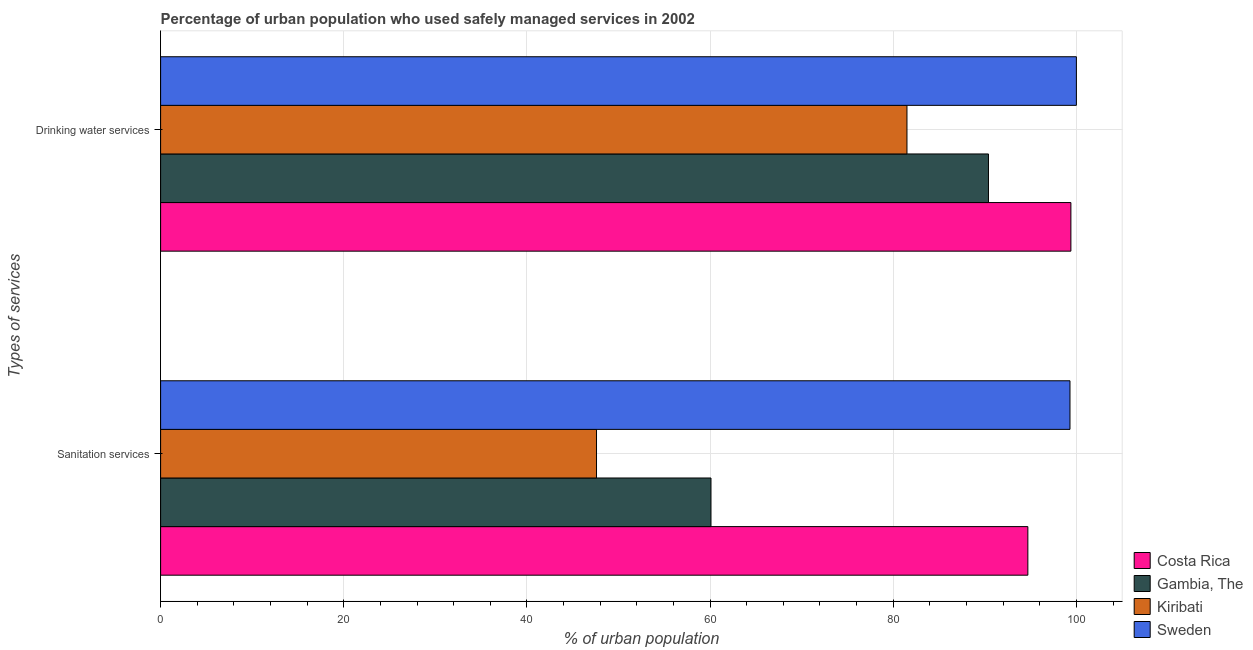How many groups of bars are there?
Offer a very short reply. 2. Are the number of bars per tick equal to the number of legend labels?
Give a very brief answer. Yes. How many bars are there on the 1st tick from the top?
Your response must be concise. 4. How many bars are there on the 1st tick from the bottom?
Make the answer very short. 4. What is the label of the 2nd group of bars from the top?
Give a very brief answer. Sanitation services. What is the percentage of urban population who used drinking water services in Costa Rica?
Keep it short and to the point. 99.4. Across all countries, what is the maximum percentage of urban population who used drinking water services?
Provide a short and direct response. 100. Across all countries, what is the minimum percentage of urban population who used sanitation services?
Your answer should be very brief. 47.6. In which country was the percentage of urban population who used drinking water services minimum?
Offer a terse response. Kiribati. What is the total percentage of urban population who used sanitation services in the graph?
Offer a very short reply. 301.7. What is the difference between the percentage of urban population who used drinking water services in Costa Rica and that in Sweden?
Your answer should be compact. -0.6. What is the difference between the percentage of urban population who used sanitation services in Costa Rica and the percentage of urban population who used drinking water services in Sweden?
Give a very brief answer. -5.3. What is the average percentage of urban population who used sanitation services per country?
Your answer should be very brief. 75.42. What is the difference between the percentage of urban population who used drinking water services and percentage of urban population who used sanitation services in Costa Rica?
Your response must be concise. 4.7. In how many countries, is the percentage of urban population who used drinking water services greater than 96 %?
Offer a terse response. 2. What is the ratio of the percentage of urban population who used sanitation services in Kiribati to that in Gambia, The?
Make the answer very short. 0.79. What does the 3rd bar from the top in Sanitation services represents?
Ensure brevity in your answer.  Gambia, The. What does the 3rd bar from the bottom in Drinking water services represents?
Ensure brevity in your answer.  Kiribati. Are all the bars in the graph horizontal?
Your answer should be very brief. Yes. How many countries are there in the graph?
Offer a very short reply. 4. What is the difference between two consecutive major ticks on the X-axis?
Offer a terse response. 20. Does the graph contain any zero values?
Make the answer very short. No. Does the graph contain grids?
Keep it short and to the point. Yes. Where does the legend appear in the graph?
Offer a very short reply. Bottom right. What is the title of the graph?
Ensure brevity in your answer.  Percentage of urban population who used safely managed services in 2002. What is the label or title of the X-axis?
Your answer should be very brief. % of urban population. What is the label or title of the Y-axis?
Offer a terse response. Types of services. What is the % of urban population of Costa Rica in Sanitation services?
Keep it short and to the point. 94.7. What is the % of urban population of Gambia, The in Sanitation services?
Offer a very short reply. 60.1. What is the % of urban population of Kiribati in Sanitation services?
Provide a short and direct response. 47.6. What is the % of urban population of Sweden in Sanitation services?
Provide a short and direct response. 99.3. What is the % of urban population of Costa Rica in Drinking water services?
Provide a succinct answer. 99.4. What is the % of urban population of Gambia, The in Drinking water services?
Provide a short and direct response. 90.4. What is the % of urban population of Kiribati in Drinking water services?
Your answer should be compact. 81.5. What is the % of urban population in Sweden in Drinking water services?
Provide a short and direct response. 100. Across all Types of services, what is the maximum % of urban population in Costa Rica?
Keep it short and to the point. 99.4. Across all Types of services, what is the maximum % of urban population of Gambia, The?
Provide a succinct answer. 90.4. Across all Types of services, what is the maximum % of urban population of Kiribati?
Ensure brevity in your answer.  81.5. Across all Types of services, what is the minimum % of urban population in Costa Rica?
Keep it short and to the point. 94.7. Across all Types of services, what is the minimum % of urban population of Gambia, The?
Make the answer very short. 60.1. Across all Types of services, what is the minimum % of urban population of Kiribati?
Offer a very short reply. 47.6. Across all Types of services, what is the minimum % of urban population of Sweden?
Give a very brief answer. 99.3. What is the total % of urban population in Costa Rica in the graph?
Your answer should be compact. 194.1. What is the total % of urban population in Gambia, The in the graph?
Offer a terse response. 150.5. What is the total % of urban population in Kiribati in the graph?
Keep it short and to the point. 129.1. What is the total % of urban population of Sweden in the graph?
Keep it short and to the point. 199.3. What is the difference between the % of urban population of Gambia, The in Sanitation services and that in Drinking water services?
Offer a very short reply. -30.3. What is the difference between the % of urban population of Kiribati in Sanitation services and that in Drinking water services?
Your answer should be compact. -33.9. What is the difference between the % of urban population in Sweden in Sanitation services and that in Drinking water services?
Offer a terse response. -0.7. What is the difference between the % of urban population in Costa Rica in Sanitation services and the % of urban population in Gambia, The in Drinking water services?
Provide a succinct answer. 4.3. What is the difference between the % of urban population in Costa Rica in Sanitation services and the % of urban population in Kiribati in Drinking water services?
Make the answer very short. 13.2. What is the difference between the % of urban population in Gambia, The in Sanitation services and the % of urban population in Kiribati in Drinking water services?
Your answer should be very brief. -21.4. What is the difference between the % of urban population of Gambia, The in Sanitation services and the % of urban population of Sweden in Drinking water services?
Offer a very short reply. -39.9. What is the difference between the % of urban population in Kiribati in Sanitation services and the % of urban population in Sweden in Drinking water services?
Provide a succinct answer. -52.4. What is the average % of urban population of Costa Rica per Types of services?
Your response must be concise. 97.05. What is the average % of urban population in Gambia, The per Types of services?
Your response must be concise. 75.25. What is the average % of urban population in Kiribati per Types of services?
Your answer should be very brief. 64.55. What is the average % of urban population in Sweden per Types of services?
Offer a terse response. 99.65. What is the difference between the % of urban population of Costa Rica and % of urban population of Gambia, The in Sanitation services?
Provide a short and direct response. 34.6. What is the difference between the % of urban population in Costa Rica and % of urban population in Kiribati in Sanitation services?
Offer a very short reply. 47.1. What is the difference between the % of urban population of Gambia, The and % of urban population of Sweden in Sanitation services?
Your response must be concise. -39.2. What is the difference between the % of urban population of Kiribati and % of urban population of Sweden in Sanitation services?
Your response must be concise. -51.7. What is the difference between the % of urban population in Costa Rica and % of urban population in Gambia, The in Drinking water services?
Offer a very short reply. 9. What is the difference between the % of urban population in Costa Rica and % of urban population in Kiribati in Drinking water services?
Make the answer very short. 17.9. What is the difference between the % of urban population in Kiribati and % of urban population in Sweden in Drinking water services?
Give a very brief answer. -18.5. What is the ratio of the % of urban population in Costa Rica in Sanitation services to that in Drinking water services?
Your answer should be very brief. 0.95. What is the ratio of the % of urban population of Gambia, The in Sanitation services to that in Drinking water services?
Make the answer very short. 0.66. What is the ratio of the % of urban population of Kiribati in Sanitation services to that in Drinking water services?
Your answer should be very brief. 0.58. What is the ratio of the % of urban population in Sweden in Sanitation services to that in Drinking water services?
Offer a terse response. 0.99. What is the difference between the highest and the second highest % of urban population in Gambia, The?
Offer a terse response. 30.3. What is the difference between the highest and the second highest % of urban population of Kiribati?
Make the answer very short. 33.9. What is the difference between the highest and the lowest % of urban population of Gambia, The?
Your answer should be very brief. 30.3. What is the difference between the highest and the lowest % of urban population of Kiribati?
Offer a terse response. 33.9. 